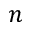Convert formula to latex. <formula><loc_0><loc_0><loc_500><loc_500>n</formula> 